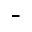Convert formula to latex. <formula><loc_0><loc_0><loc_500><loc_500>^ { - }</formula> 